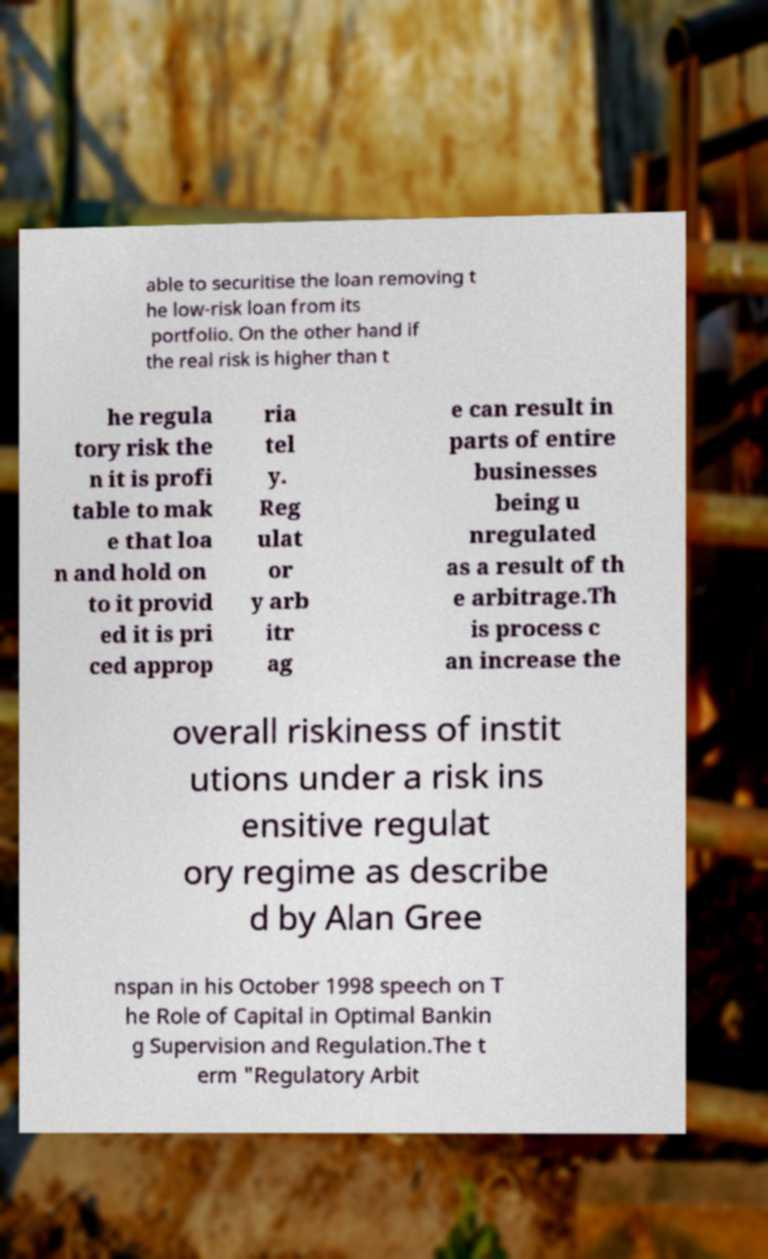I need the written content from this picture converted into text. Can you do that? able to securitise the loan removing t he low-risk loan from its portfolio. On the other hand if the real risk is higher than t he regula tory risk the n it is profi table to mak e that loa n and hold on to it provid ed it is pri ced approp ria tel y. Reg ulat or y arb itr ag e can result in parts of entire businesses being u nregulated as a result of th e arbitrage.Th is process c an increase the overall riskiness of instit utions under a risk ins ensitive regulat ory regime as describe d by Alan Gree nspan in his October 1998 speech on T he Role of Capital in Optimal Bankin g Supervision and Regulation.The t erm "Regulatory Arbit 